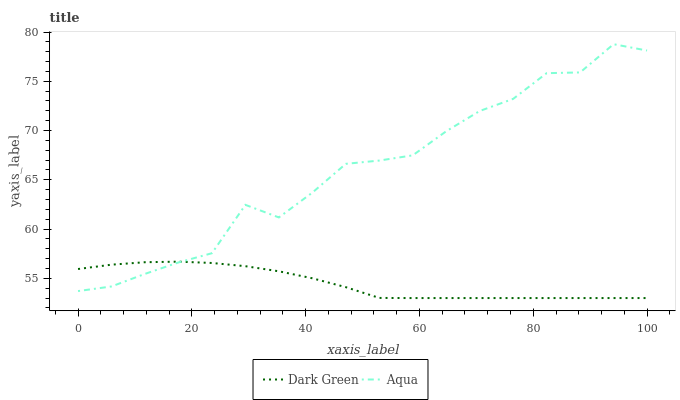Does Dark Green have the minimum area under the curve?
Answer yes or no. Yes. Does Aqua have the maximum area under the curve?
Answer yes or no. Yes. Does Dark Green have the maximum area under the curve?
Answer yes or no. No. Is Dark Green the smoothest?
Answer yes or no. Yes. Is Aqua the roughest?
Answer yes or no. Yes. Is Dark Green the roughest?
Answer yes or no. No. Does Dark Green have the lowest value?
Answer yes or no. Yes. Does Aqua have the highest value?
Answer yes or no. Yes. Does Dark Green have the highest value?
Answer yes or no. No. Does Aqua intersect Dark Green?
Answer yes or no. Yes. Is Aqua less than Dark Green?
Answer yes or no. No. Is Aqua greater than Dark Green?
Answer yes or no. No. 